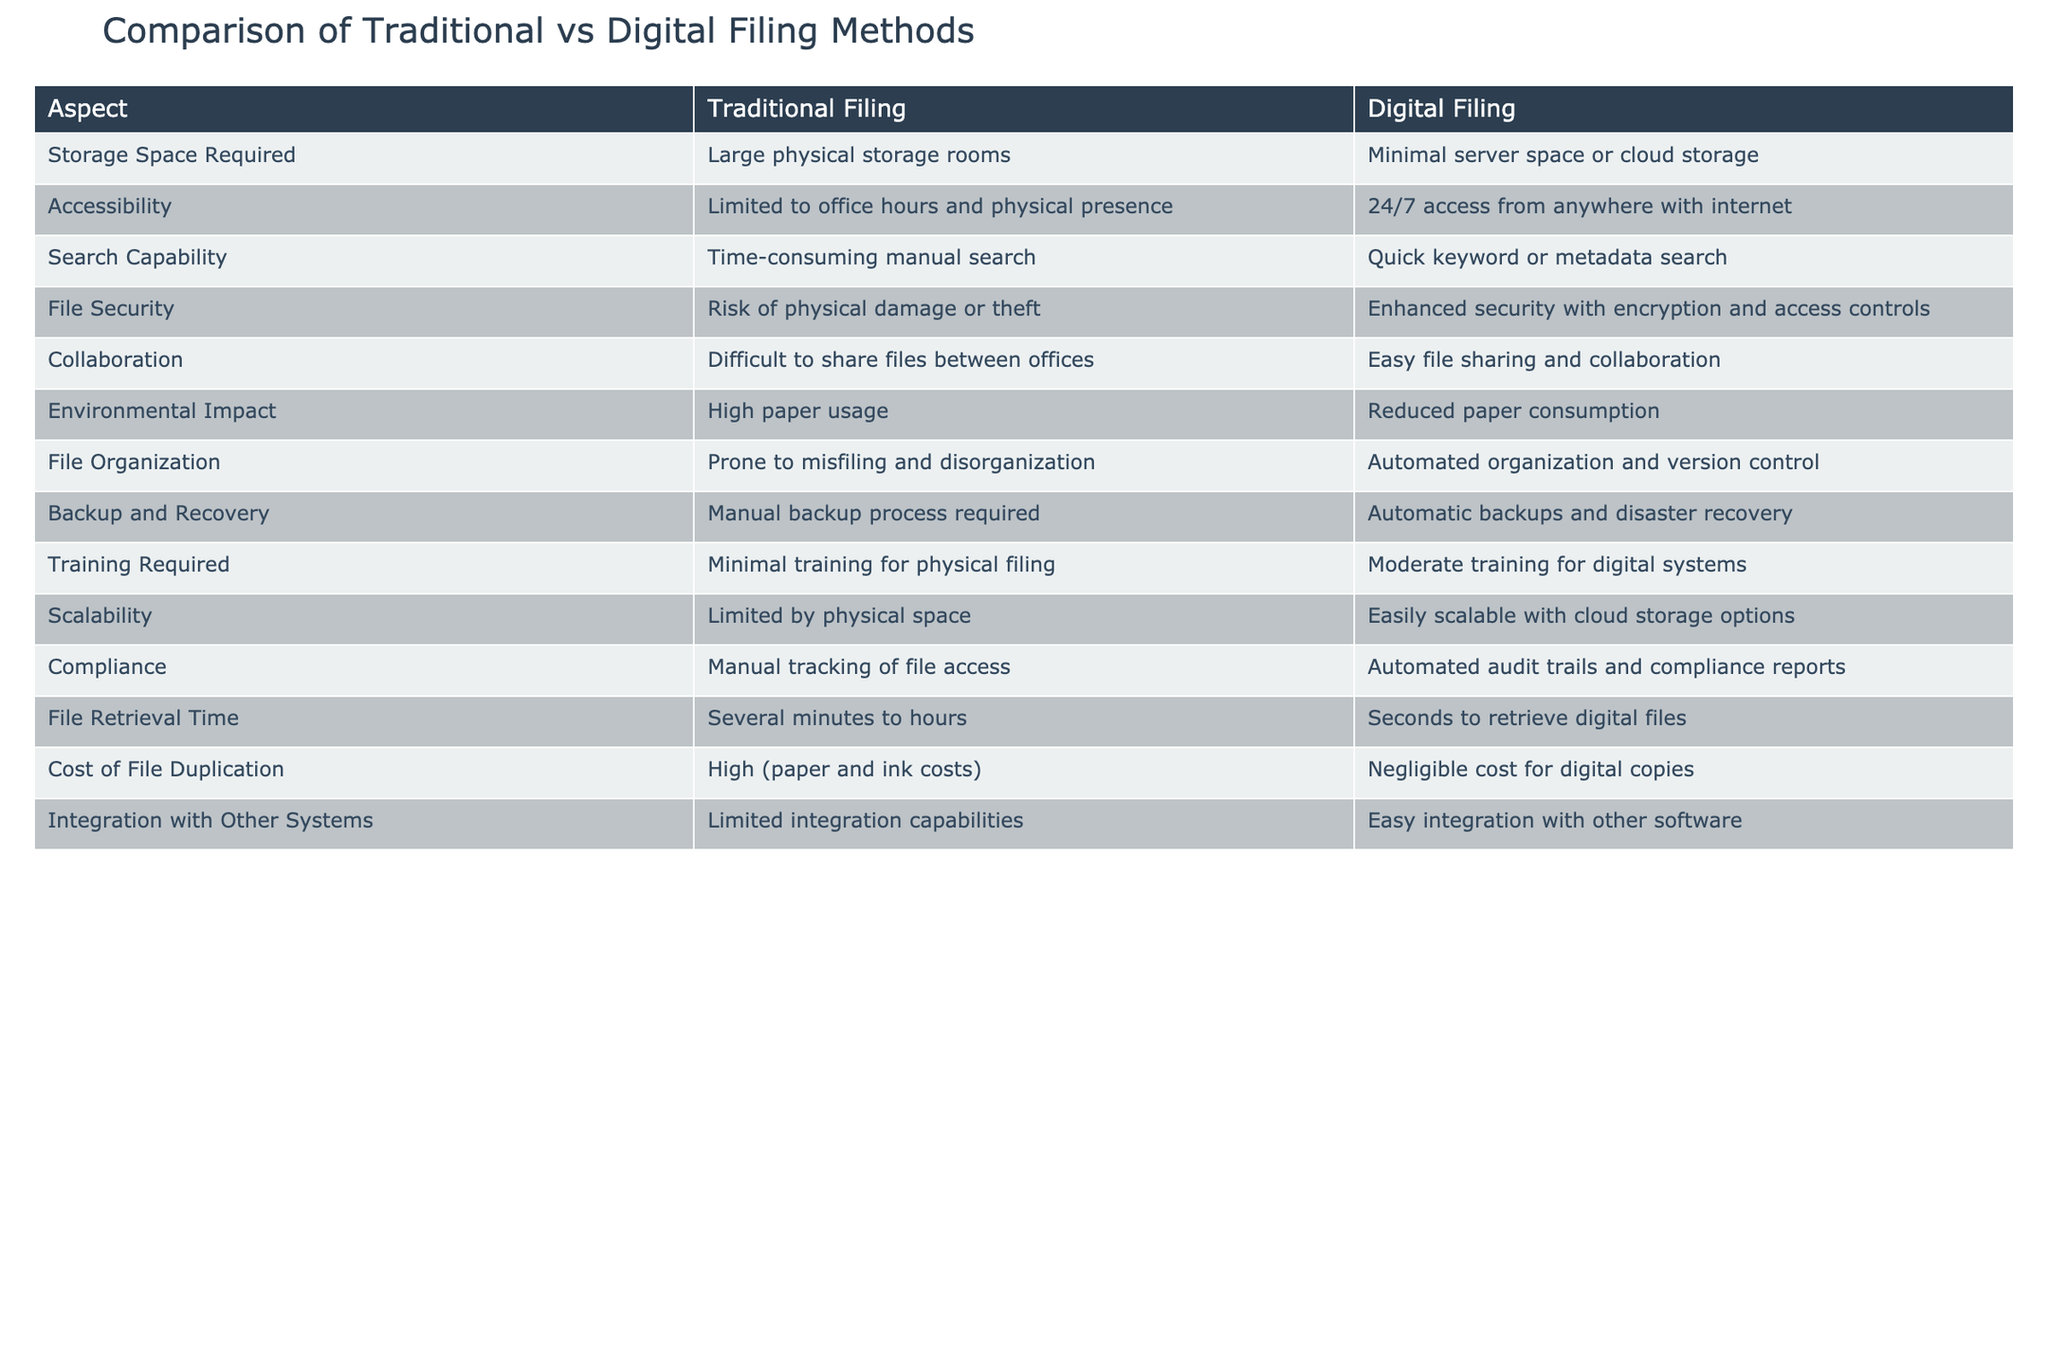What is the storage space required for traditional filing? The table states that traditional filing requires "Large physical storage rooms." This is a direct retrieval from the relevant row under the aspect of storage space required.
Answer: Large physical storage rooms How many aspects provide advantages for digital filing compared to traditional filing? By examining the table, there are 7 aspects where digital filing is noted to have an advantage over traditional filing (Accessibility, Search Capability, File Security, Collaboration, Environmental Impact, Backup and Recovery, File Retrieval Time).
Answer: 7 Is file security enhanced in digital filing? The table indicates that digital filing has "Enhanced security with encryption and access controls," which clearly confirms that file security is improved. Therefore, the answer is yes.
Answer: Yes Which filing method offers easier scalability? Looking at the scalability aspect, the table notes that traditional filing is "Limited by physical space" while digital filing is "Easily scalable with cloud storage options." Thus, digital filing is more scalable.
Answer: Digital filing What is the difference in file retrieval time between traditional and digital filing? The retrieval time for traditional filing is noted as "Several minutes to hours," while for digital filing, it is "Seconds to retrieve digital files." The difference indicates digital filing is significantly faster than traditional filing, emphasizing the efficiency of digital methods.
Answer: Digital filing is faster; seconds vs. minutes/hours How does the environmental impact differ between the two filing methods? From the environmental impact row, we see traditional filing has "High paper usage," whereas digital filing is characterized by "Reduced paper consumption." This comparison suggests that digital filing is more environmentally friendly due to lower paper use.
Answer: Digital filing is more environmentally friendly Does traditional filing require more training than digital filing? The table indicates that traditional filing requires "Minimal training for physical filing," while digital filing requires "Moderate training for digital systems." This comparison shows that more training is needed for digital filing, meaning traditional filing requires less training.
Answer: No, traditional filing requires less training Calculate the average training requirement for both filing methods based on the general descriptions provided: minimal and moderate. If we consider "Minimal training" as a value of 1 and "Moderate training" as 2 (assuming a simple scale), then the average training requirement would be (1 + 2) / 2 = 1.5. Therefore, the average training reflects a midway point indicating some challenge in training for users switching from traditional to digital filing systems.
Answer: 1.5 